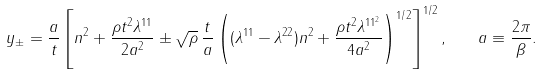<formula> <loc_0><loc_0><loc_500><loc_500>y _ { \pm } = \frac { a } { t } \left [ n ^ { 2 } + \frac { \rho t ^ { 2 } \lambda ^ { 1 1 } } { 2 a ^ { 2 } } \pm \sqrt { \rho } \, \frac { t } { a } \left ( ( \lambda ^ { 1 1 } - \lambda ^ { 2 2 } ) n ^ { 2 } + \frac { \rho t ^ { 2 } \lambda ^ { 1 1 ^ { 2 } } } { 4 a ^ { 2 } } \right ) ^ { 1 / 2 } \right ] ^ { 1 / 2 } , \quad a \equiv \frac { 2 \pi } { \beta } .</formula> 